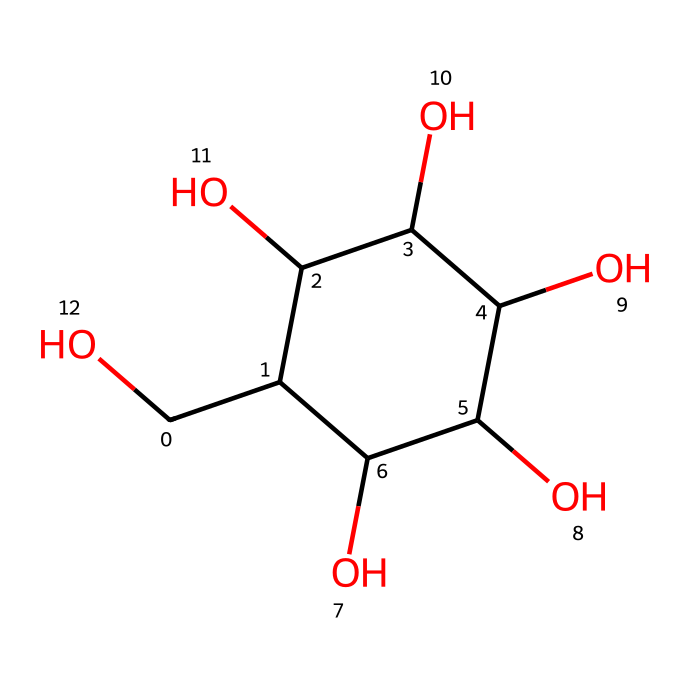How many carbon atoms are present in glucose? By examining the SMILES representation, each "C" corresponds to a carbon atom. Counting them yields a total of six carbon atoms.
Answer: six What is the molecular formula of glucose? The chemical structure reveals six carbon atoms, twelve hydrogen atoms, and six oxygen atoms, which combines to form the molecular formula C6H12O6.
Answer: C6H12O6 Does glucose contain any rings in its structure? The structure includes a ring, as evidenced by the notation related to the carbon atoms at the beginning and end (C1). This indicates a cyclic structure.
Answer: yes What types of bonds are primarily present in glucose? The structure displays several single bonds connecting carbon, hydrogen, and oxygen atoms, indicating the dominance of covalent bonding throughout its composition.
Answer: covalent Is glucose an electrolyte? Glucose is classified as a non-electrolyte because it does not dissociate into ions in solution and, therefore, does not conduct electricity.
Answer: no How many hydroxyl groups are in glucose? The structure contains five hydroxyl (-OH) groups, evident from the presence of five oxygen atoms connected to hydrogen atoms. Each -OH group represents a hydroxyl.
Answer: five What role does glucose play in human metabolism? Glucose is a primary energy source for the body and is central to cellular respiration, where it is metabolized to produce ATP, the energy currency of cells.
Answer: energy source 